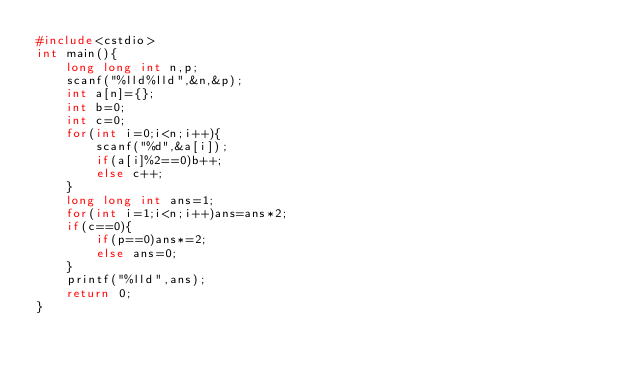Convert code to text. <code><loc_0><loc_0><loc_500><loc_500><_C++_>#include<cstdio>
int main(){
	long long int n,p;
	scanf("%lld%lld",&n,&p);
	int a[n]={};
	int b=0;
	int c=0;
	for(int i=0;i<n;i++){
		scanf("%d",&a[i]);
		if(a[i]%2==0)b++;
		else c++;
	}
	long long int ans=1;
	for(int i=1;i<n;i++)ans=ans*2;
	if(c==0){
		if(p==0)ans*=2;
		else ans=0;
	}
	printf("%lld",ans);
	return 0;
}
	</code> 